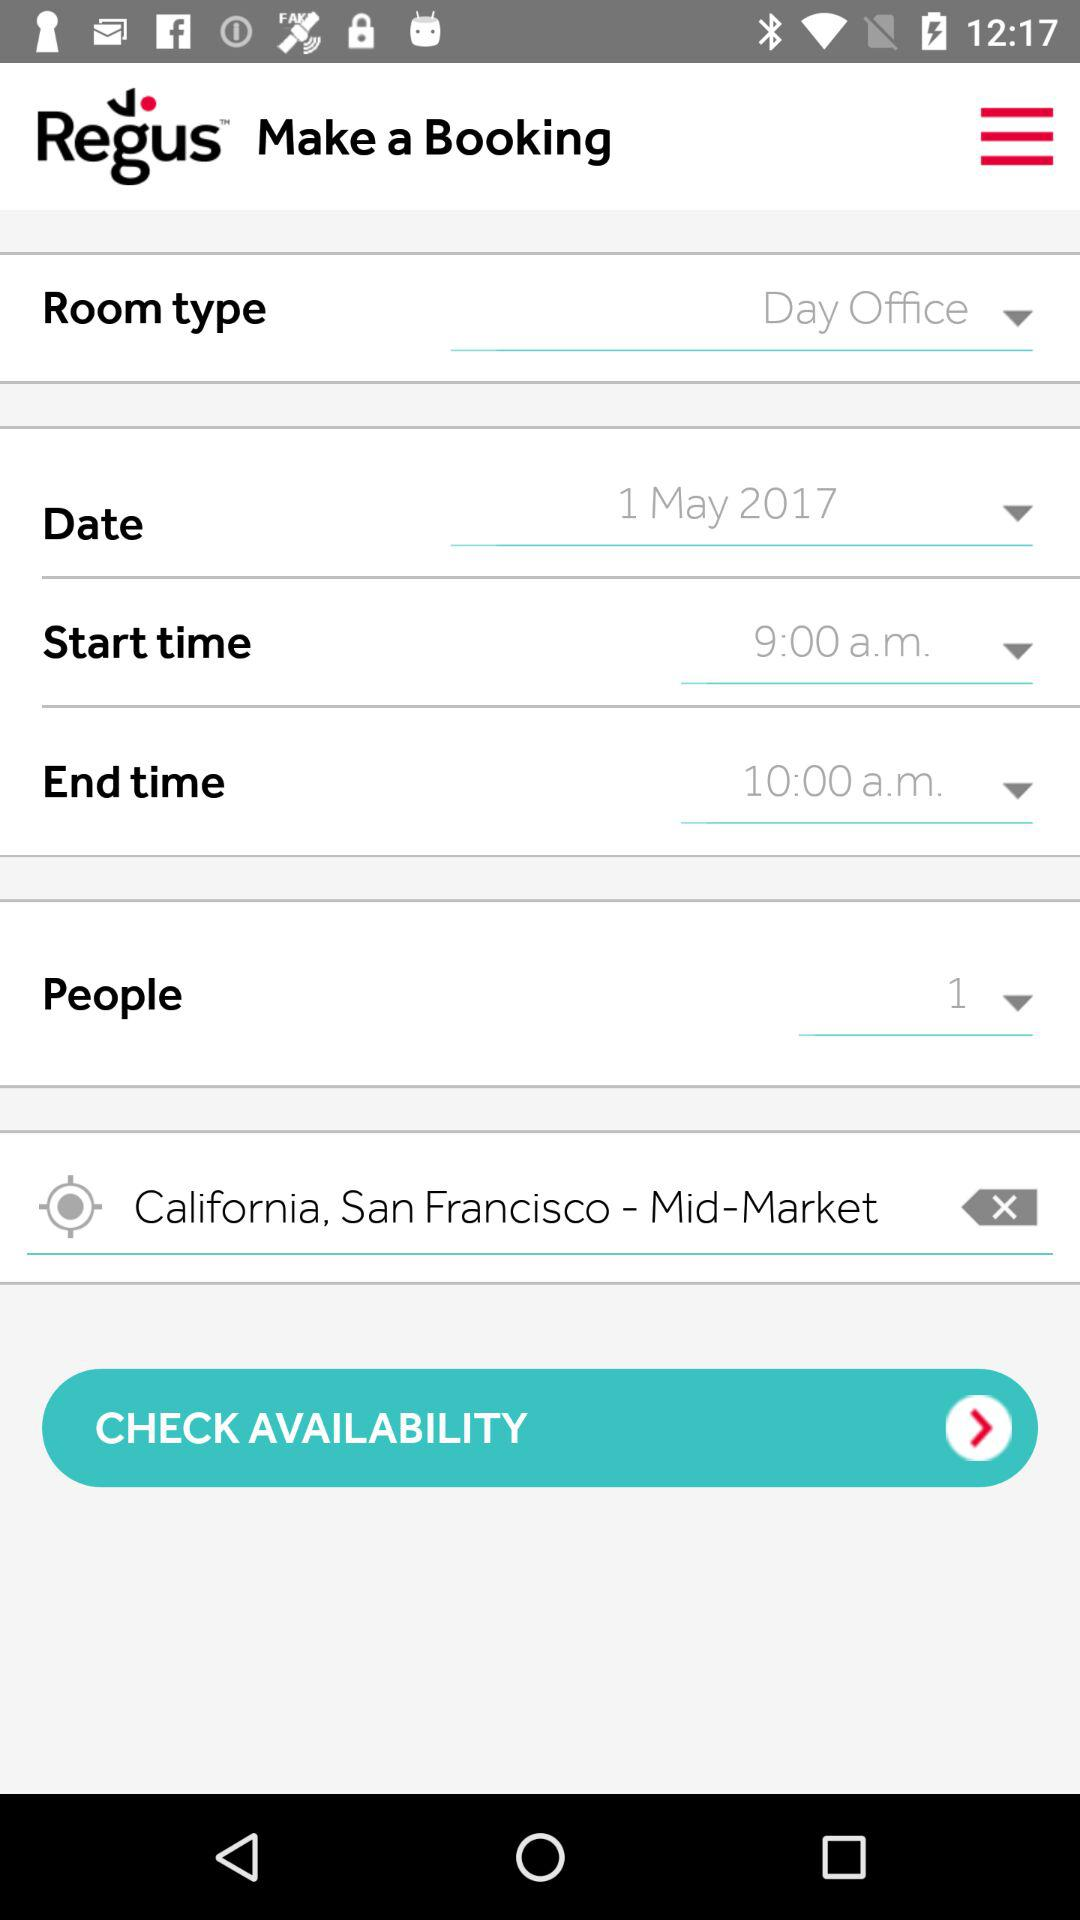What is the end time? The end time is 10:00 a.m. 